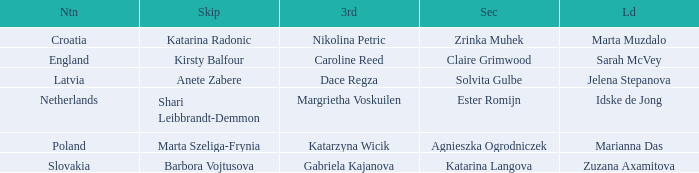Which lead has Kirsty Balfour as second? Sarah McVey. 